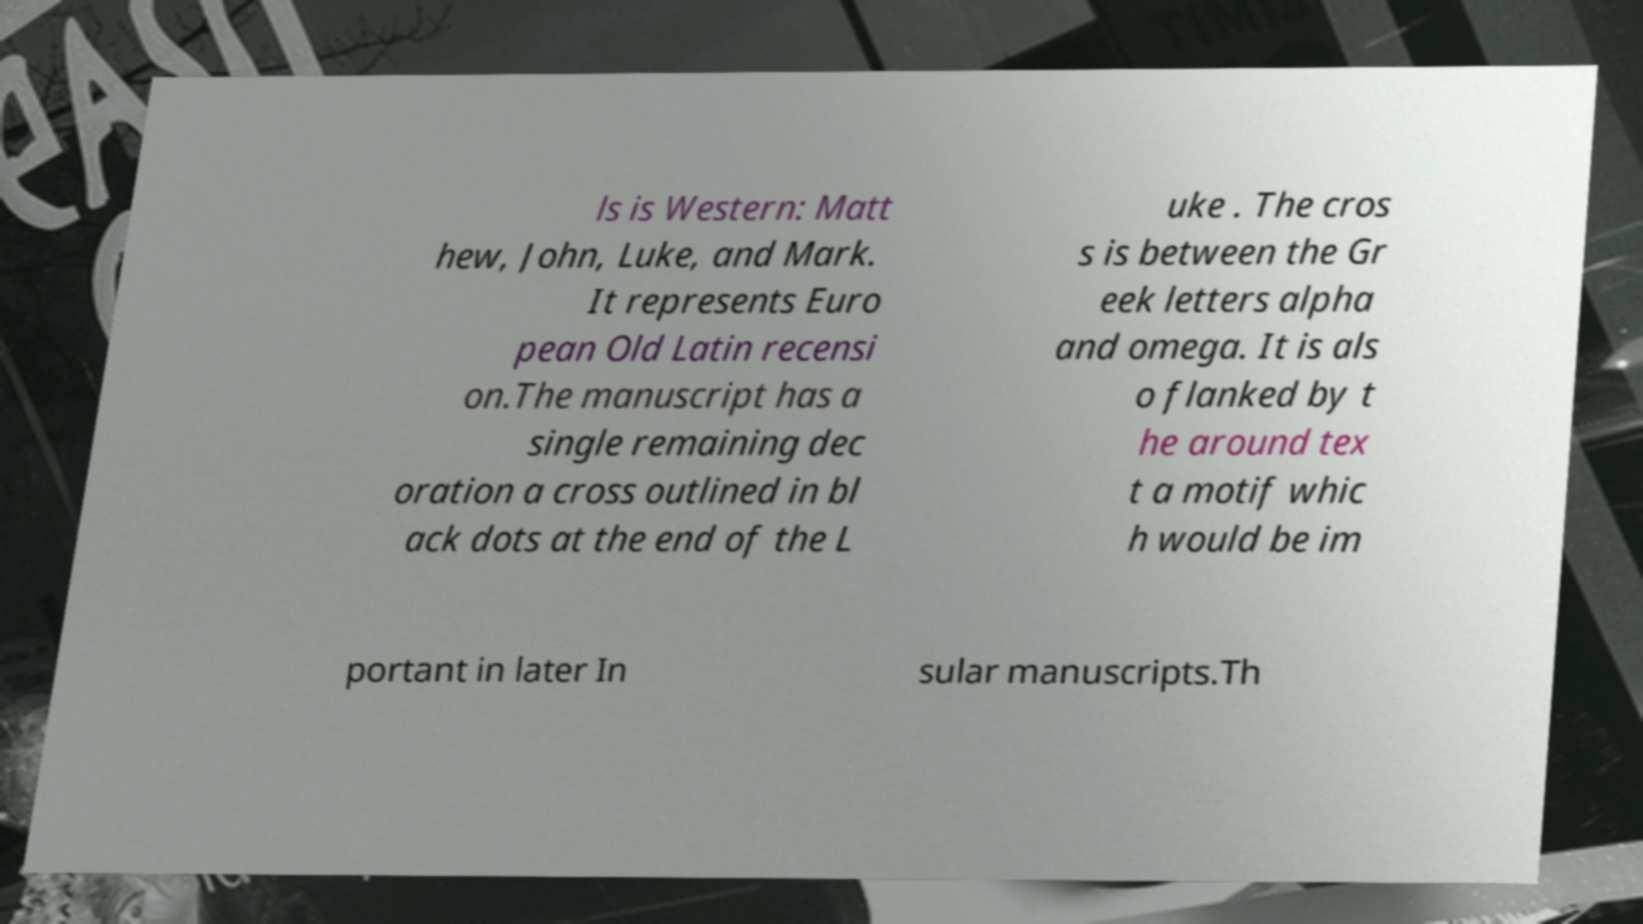Can you accurately transcribe the text from the provided image for me? ls is Western: Matt hew, John, Luke, and Mark. It represents Euro pean Old Latin recensi on.The manuscript has a single remaining dec oration a cross outlined in bl ack dots at the end of the L uke . The cros s is between the Gr eek letters alpha and omega. It is als o flanked by t he around tex t a motif whic h would be im portant in later In sular manuscripts.Th 